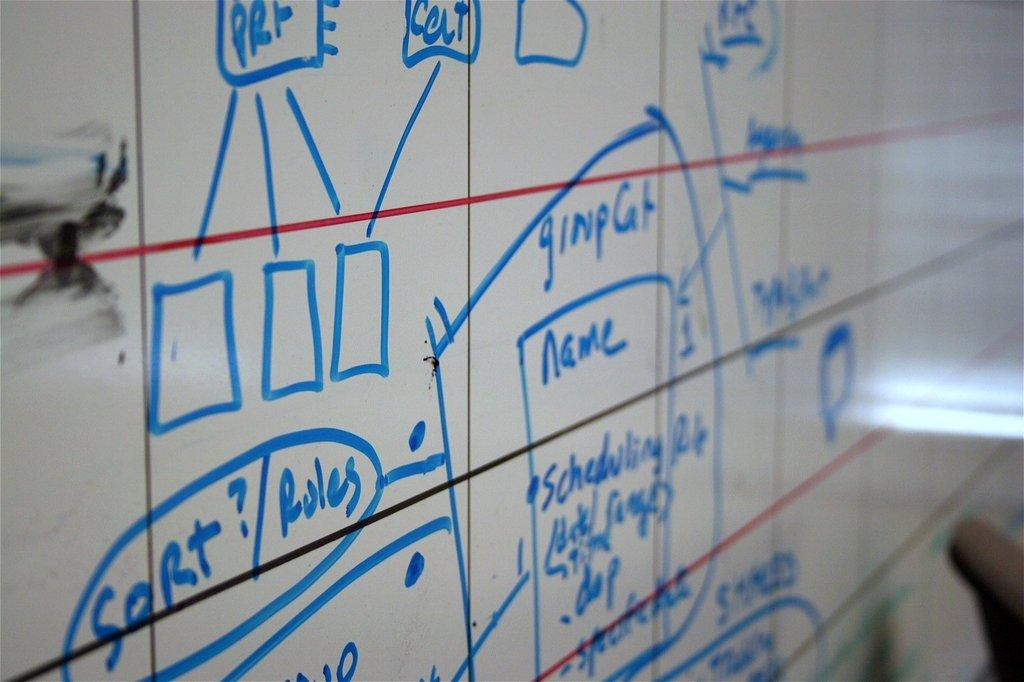<image>
Relay a brief, clear account of the picture shown. A white board with a chart that says the word name on it and has other words written in blue marker. 